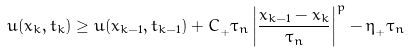<formula> <loc_0><loc_0><loc_500><loc_500>u ( x _ { k } , t _ { k } ) \geq u ( x _ { k - 1 } , t _ { k - 1 } ) + C _ { _ { + } } \tau _ { n } \left | \frac { x _ { k - 1 } - x _ { k } } { \tau _ { n } } \right | ^ { p } - \eta _ { _ { + } } \tau _ { n }</formula> 